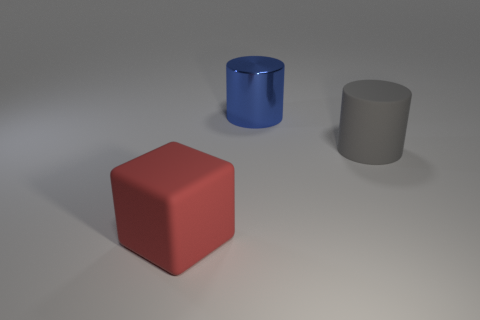Add 2 tiny red rubber balls. How many objects exist? 5 Subtract all cubes. How many objects are left? 2 Add 2 big red matte things. How many big red matte things are left? 3 Add 2 blue metallic things. How many blue metallic things exist? 3 Subtract 0 gray spheres. How many objects are left? 3 Subtract all large red rubber things. Subtract all large rubber cylinders. How many objects are left? 1 